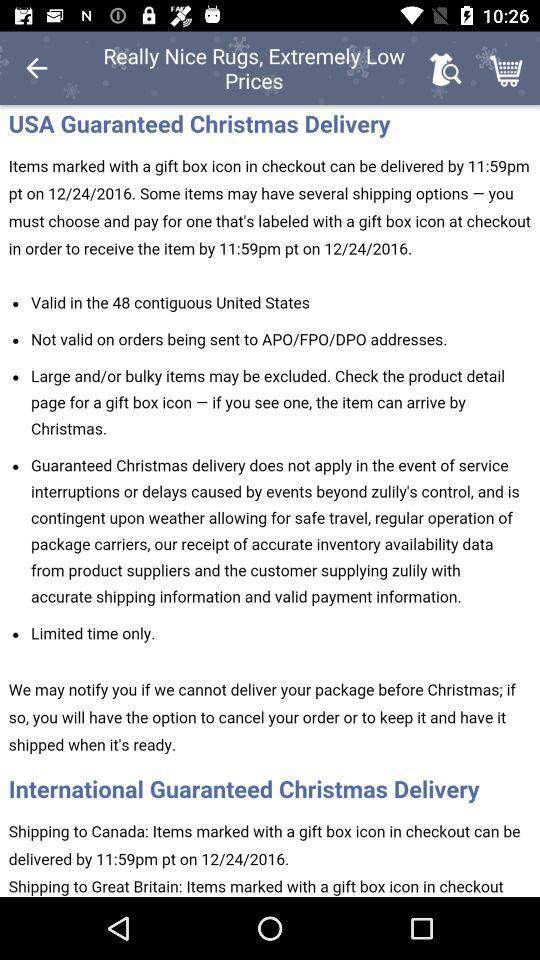By what time items marked with a gift box icon in checkout can be delivered? It can be delivered by 11:59pm. 